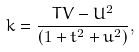<formula> <loc_0><loc_0><loc_500><loc_500>k = \frac { T V - U ^ { 2 } } { ( 1 + t ^ { 2 } + u ^ { 2 } ) } ,</formula> 